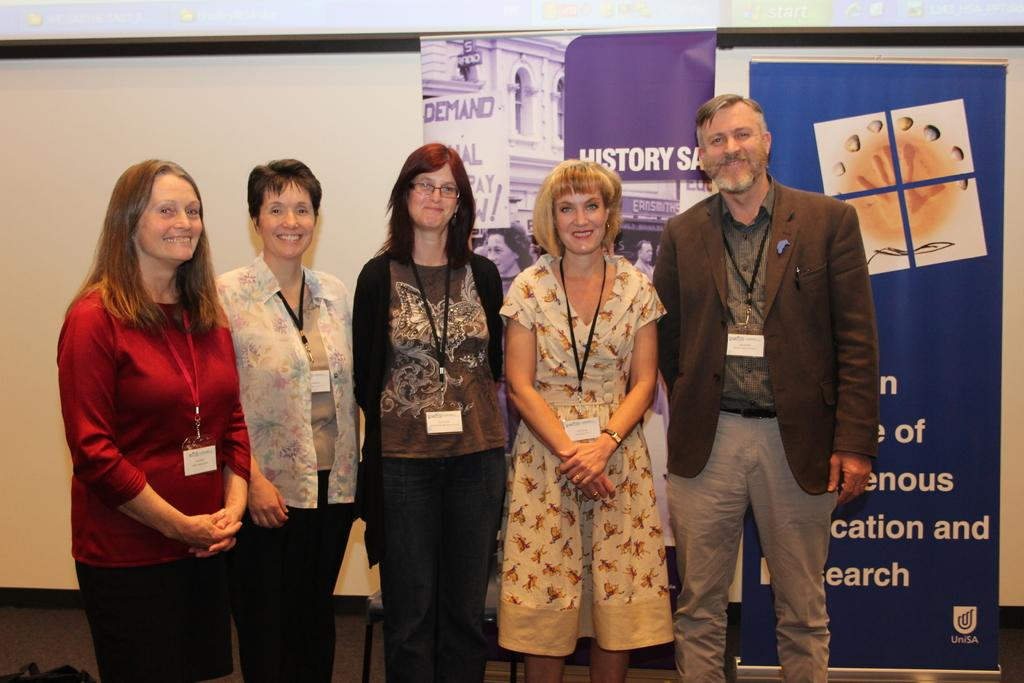How many people are present in the image? There are five people in the image. What are the people wearing that can be seen in the image? The people are wearing ID cards. What is the facial expression of the people in the image? The people are smiling. What position are the people in the image? The people are standing. What can be seen in the background of the image? There is a wall, a chair, and banners in the background of the image. How many pipes are visible in the image? There are no pipes present in the image. What type of women are featured in the image? The provided facts do not mention any women in the image; there are only five people, and their genders are not specified. 